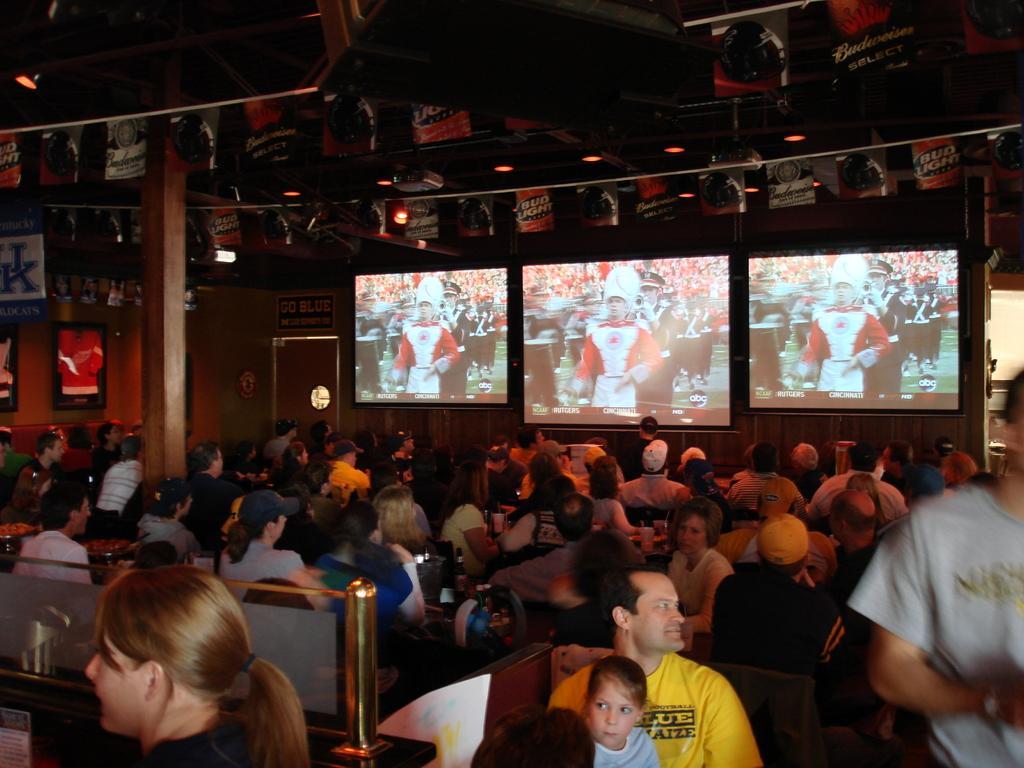Can you describe this image briefly? In this image we can see few persons are sitting on the chairs at the tables and we can see bottles and objects on the tables. On the right side a person is standing. In the background we can see screens, boards on the wall, door, small posters tied to the ropes, lights and other objects. 